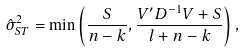Convert formula to latex. <formula><loc_0><loc_0><loc_500><loc_500>\hat { \sigma } ^ { 2 } _ { S T } = \min \left ( \frac { S } { n - k } , \frac { V ^ { \prime } D ^ { - 1 } V + S } { l + n - k } \right ) ,</formula> 